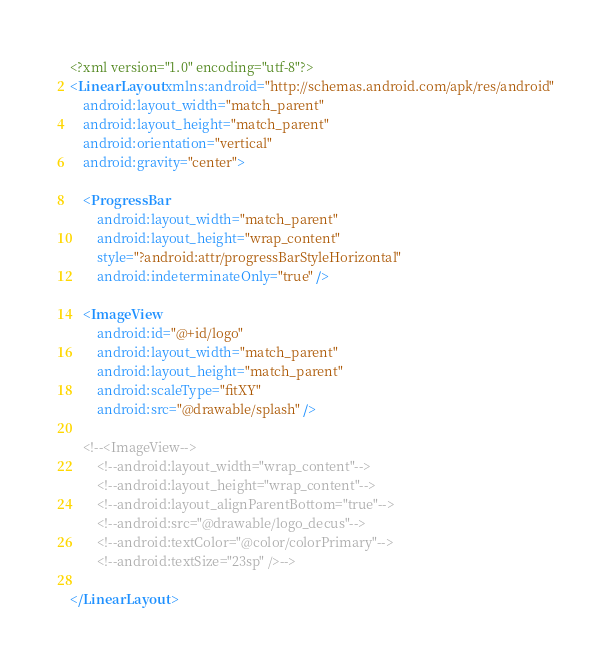<code> <loc_0><loc_0><loc_500><loc_500><_XML_><?xml version="1.0" encoding="utf-8"?>
<LinearLayout xmlns:android="http://schemas.android.com/apk/res/android"
    android:layout_width="match_parent"
    android:layout_height="match_parent"
    android:orientation="vertical"
    android:gravity="center">

    <ProgressBar
        android:layout_width="match_parent"
        android:layout_height="wrap_content"
        style="?android:attr/progressBarStyleHorizontal"
        android:indeterminateOnly="true" />

    <ImageView
        android:id="@+id/logo"
        android:layout_width="match_parent"
        android:layout_height="match_parent"
        android:scaleType="fitXY"
        android:src="@drawable/splash" />

    <!--<ImageView-->
        <!--android:layout_width="wrap_content"-->
        <!--android:layout_height="wrap_content"-->
        <!--android:layout_alignParentBottom="true"-->
        <!--android:src="@drawable/logo_decus"-->
        <!--android:textColor="@color/colorPrimary"-->
        <!--android:textSize="23sp" />-->

</LinearLayout></code> 